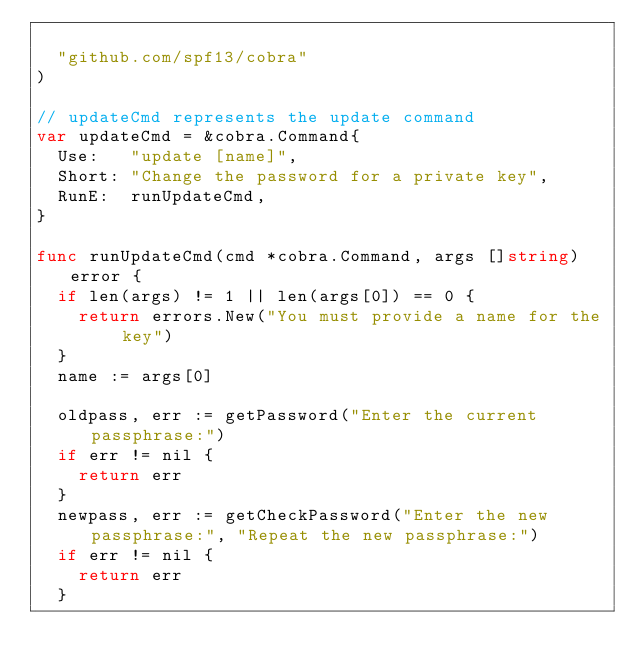<code> <loc_0><loc_0><loc_500><loc_500><_Go_>
	"github.com/spf13/cobra"
)

// updateCmd represents the update command
var updateCmd = &cobra.Command{
	Use:   "update [name]",
	Short: "Change the password for a private key",
	RunE:  runUpdateCmd,
}

func runUpdateCmd(cmd *cobra.Command, args []string) error {
	if len(args) != 1 || len(args[0]) == 0 {
		return errors.New("You must provide a name for the key")
	}
	name := args[0]

	oldpass, err := getPassword("Enter the current passphrase:")
	if err != nil {
		return err
	}
	newpass, err := getCheckPassword("Enter the new passphrase:", "Repeat the new passphrase:")
	if err != nil {
		return err
	}
</code> 